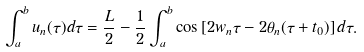<formula> <loc_0><loc_0><loc_500><loc_500>\int _ { a } ^ { b } u _ { n } ( \tau ) d \tau = \frac { L } { 2 } - \frac { 1 } { 2 } \int _ { a } ^ { b } \cos \left [ 2 w _ { n } \tau - 2 \theta _ { n } ( \tau + t _ { 0 } ) \right ] d \tau .</formula> 